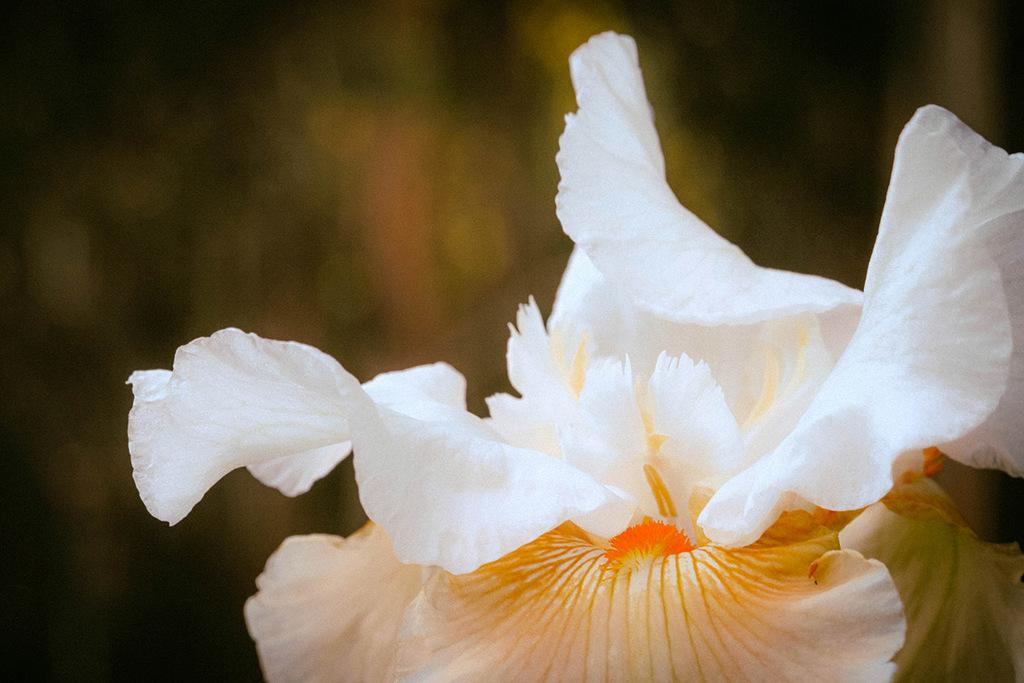What type of living organisms can be seen in the image? There are flowers in the image. Can you describe the background of the image? The background of the image is blurred. What type of fold can be seen in the earth's crust in the image? There is no reference to the earth's crust or any folds in the image, as it features flowers and a blurred background. 